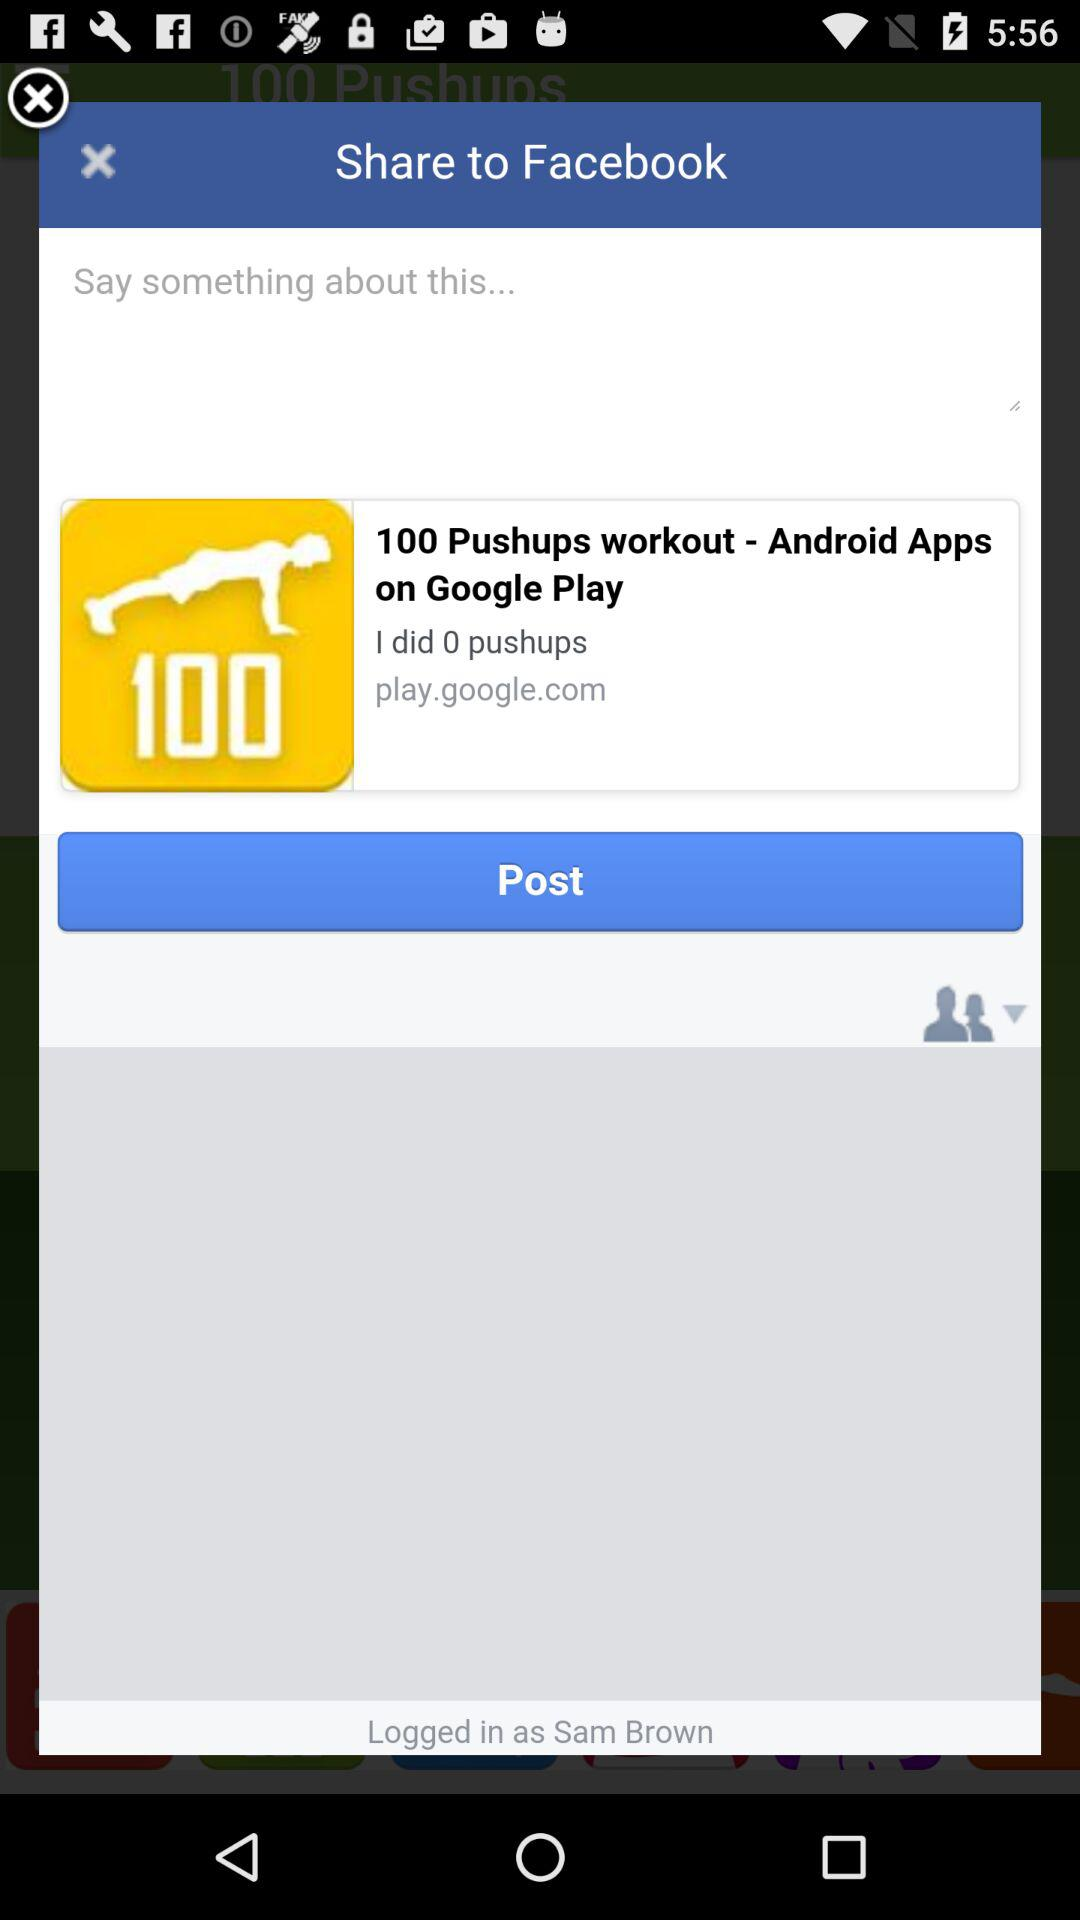How many pushups did the person do? The person did 1 pushup. 